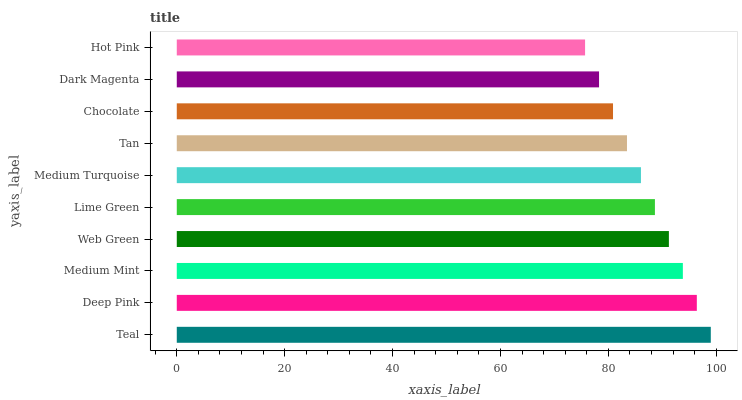Is Hot Pink the minimum?
Answer yes or no. Yes. Is Teal the maximum?
Answer yes or no. Yes. Is Deep Pink the minimum?
Answer yes or no. No. Is Deep Pink the maximum?
Answer yes or no. No. Is Teal greater than Deep Pink?
Answer yes or no. Yes. Is Deep Pink less than Teal?
Answer yes or no. Yes. Is Deep Pink greater than Teal?
Answer yes or no. No. Is Teal less than Deep Pink?
Answer yes or no. No. Is Lime Green the high median?
Answer yes or no. Yes. Is Medium Turquoise the low median?
Answer yes or no. Yes. Is Teal the high median?
Answer yes or no. No. Is Deep Pink the low median?
Answer yes or no. No. 